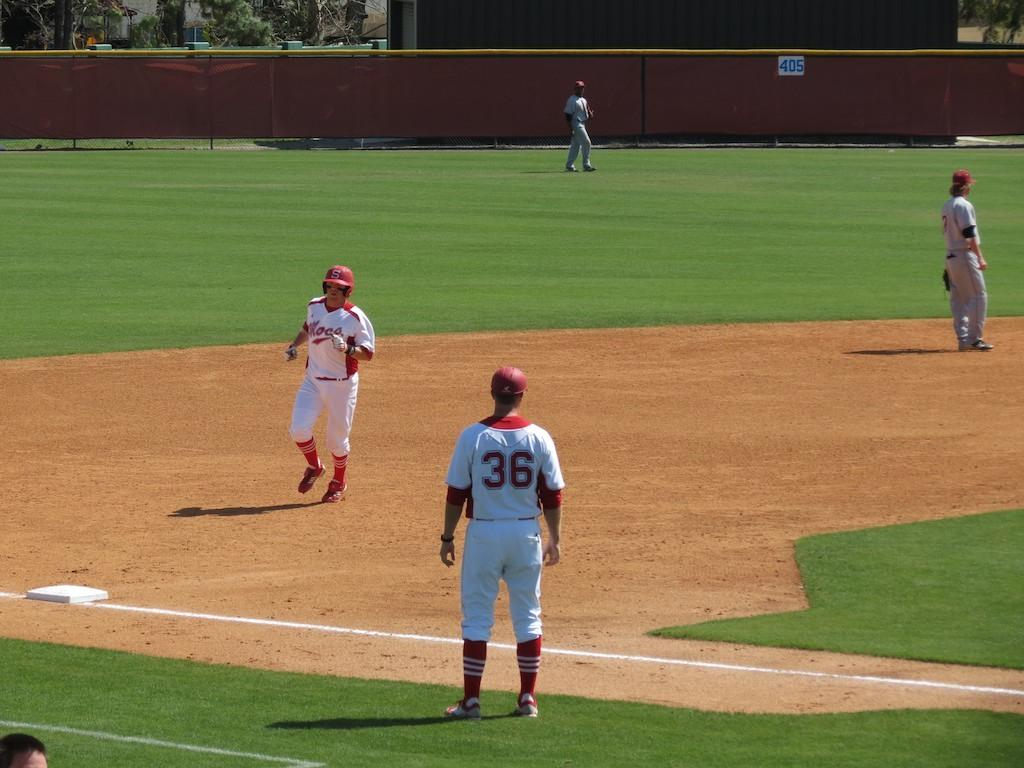<image>
Provide a brief description of the given image. Ball players on the field with a 405 in blue letters on the back fence. 